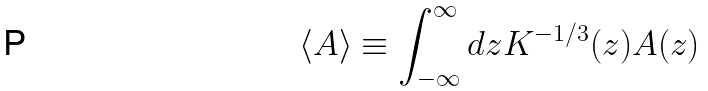<formula> <loc_0><loc_0><loc_500><loc_500>\langle A \rangle \equiv \int _ { - \infty } ^ { \infty } d z K ^ { - 1 / 3 } ( z ) A ( z )</formula> 